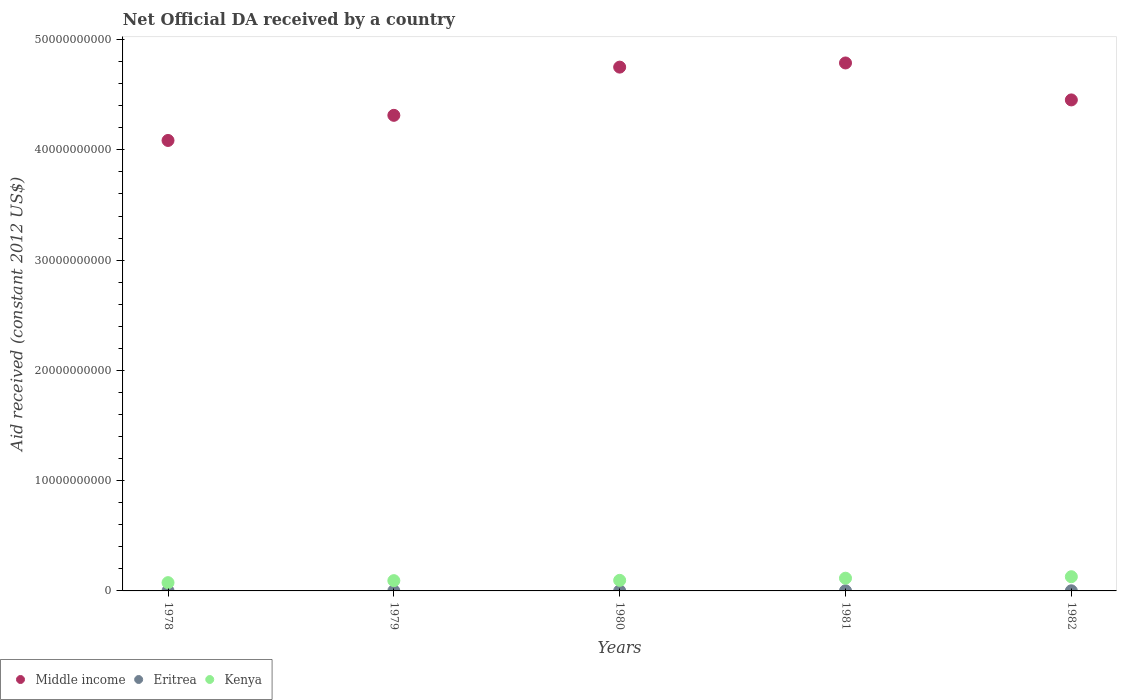What is the net official development assistance aid received in Kenya in 1978?
Your answer should be compact. 7.51e+08. Across all years, what is the maximum net official development assistance aid received in Eritrea?
Offer a very short reply. 1.46e+07. Across all years, what is the minimum net official development assistance aid received in Kenya?
Give a very brief answer. 7.51e+08. In which year was the net official development assistance aid received in Middle income maximum?
Offer a terse response. 1981. In which year was the net official development assistance aid received in Kenya minimum?
Provide a short and direct response. 1978. What is the total net official development assistance aid received in Eritrea in the graph?
Provide a succinct answer. 6.26e+07. What is the difference between the net official development assistance aid received in Eritrea in 1978 and that in 1980?
Your answer should be compact. 3.21e+06. What is the difference between the net official development assistance aid received in Middle income in 1979 and the net official development assistance aid received in Kenya in 1981?
Provide a short and direct response. 4.20e+1. What is the average net official development assistance aid received in Middle income per year?
Keep it short and to the point. 4.48e+1. In the year 1981, what is the difference between the net official development assistance aid received in Eritrea and net official development assistance aid received in Kenya?
Make the answer very short. -1.14e+09. In how many years, is the net official development assistance aid received in Middle income greater than 20000000000 US$?
Ensure brevity in your answer.  5. What is the ratio of the net official development assistance aid received in Eritrea in 1978 to that in 1980?
Offer a terse response. 1.28. Is the difference between the net official development assistance aid received in Eritrea in 1981 and 1982 greater than the difference between the net official development assistance aid received in Kenya in 1981 and 1982?
Your answer should be very brief. Yes. What is the difference between the highest and the second highest net official development assistance aid received in Middle income?
Ensure brevity in your answer.  3.77e+08. What is the difference between the highest and the lowest net official development assistance aid received in Kenya?
Ensure brevity in your answer.  5.38e+08. Is the sum of the net official development assistance aid received in Eritrea in 1979 and 1982 greater than the maximum net official development assistance aid received in Middle income across all years?
Ensure brevity in your answer.  No. Does the net official development assistance aid received in Eritrea monotonically increase over the years?
Offer a terse response. No. Is the net official development assistance aid received in Eritrea strictly greater than the net official development assistance aid received in Middle income over the years?
Make the answer very short. No. Does the graph contain any zero values?
Ensure brevity in your answer.  No. Where does the legend appear in the graph?
Ensure brevity in your answer.  Bottom left. How are the legend labels stacked?
Make the answer very short. Horizontal. What is the title of the graph?
Your answer should be compact. Net Official DA received by a country. Does "Faeroe Islands" appear as one of the legend labels in the graph?
Offer a very short reply. No. What is the label or title of the X-axis?
Keep it short and to the point. Years. What is the label or title of the Y-axis?
Your answer should be very brief. Aid received (constant 2012 US$). What is the Aid received (constant 2012 US$) of Middle income in 1978?
Give a very brief answer. 4.09e+1. What is the Aid received (constant 2012 US$) of Eritrea in 1978?
Ensure brevity in your answer.  1.46e+07. What is the Aid received (constant 2012 US$) of Kenya in 1978?
Make the answer very short. 7.51e+08. What is the Aid received (constant 2012 US$) in Middle income in 1979?
Keep it short and to the point. 4.31e+1. What is the Aid received (constant 2012 US$) of Eritrea in 1979?
Give a very brief answer. 1.10e+07. What is the Aid received (constant 2012 US$) in Kenya in 1979?
Keep it short and to the point. 9.32e+08. What is the Aid received (constant 2012 US$) in Middle income in 1980?
Your answer should be compact. 4.75e+1. What is the Aid received (constant 2012 US$) of Eritrea in 1980?
Ensure brevity in your answer.  1.14e+07. What is the Aid received (constant 2012 US$) in Kenya in 1980?
Your answer should be compact. 9.59e+08. What is the Aid received (constant 2012 US$) of Middle income in 1981?
Give a very brief answer. 4.79e+1. What is the Aid received (constant 2012 US$) in Eritrea in 1981?
Provide a succinct answer. 1.42e+07. What is the Aid received (constant 2012 US$) in Kenya in 1981?
Your answer should be compact. 1.15e+09. What is the Aid received (constant 2012 US$) in Middle income in 1982?
Your answer should be very brief. 4.45e+1. What is the Aid received (constant 2012 US$) in Eritrea in 1982?
Offer a very short reply. 1.15e+07. What is the Aid received (constant 2012 US$) in Kenya in 1982?
Your answer should be very brief. 1.29e+09. Across all years, what is the maximum Aid received (constant 2012 US$) of Middle income?
Make the answer very short. 4.79e+1. Across all years, what is the maximum Aid received (constant 2012 US$) in Eritrea?
Provide a succinct answer. 1.46e+07. Across all years, what is the maximum Aid received (constant 2012 US$) of Kenya?
Make the answer very short. 1.29e+09. Across all years, what is the minimum Aid received (constant 2012 US$) of Middle income?
Offer a very short reply. 4.09e+1. Across all years, what is the minimum Aid received (constant 2012 US$) of Eritrea?
Make the answer very short. 1.10e+07. Across all years, what is the minimum Aid received (constant 2012 US$) of Kenya?
Offer a terse response. 7.51e+08. What is the total Aid received (constant 2012 US$) in Middle income in the graph?
Your answer should be compact. 2.24e+11. What is the total Aid received (constant 2012 US$) in Eritrea in the graph?
Keep it short and to the point. 6.26e+07. What is the total Aid received (constant 2012 US$) in Kenya in the graph?
Provide a succinct answer. 5.08e+09. What is the difference between the Aid received (constant 2012 US$) in Middle income in 1978 and that in 1979?
Offer a very short reply. -2.28e+09. What is the difference between the Aid received (constant 2012 US$) in Eritrea in 1978 and that in 1979?
Give a very brief answer. 3.60e+06. What is the difference between the Aid received (constant 2012 US$) in Kenya in 1978 and that in 1979?
Your answer should be compact. -1.81e+08. What is the difference between the Aid received (constant 2012 US$) in Middle income in 1978 and that in 1980?
Offer a terse response. -6.65e+09. What is the difference between the Aid received (constant 2012 US$) in Eritrea in 1978 and that in 1980?
Your response must be concise. 3.21e+06. What is the difference between the Aid received (constant 2012 US$) in Kenya in 1978 and that in 1980?
Provide a succinct answer. -2.08e+08. What is the difference between the Aid received (constant 2012 US$) in Middle income in 1978 and that in 1981?
Offer a terse response. -7.03e+09. What is the difference between the Aid received (constant 2012 US$) of Eritrea in 1978 and that in 1981?
Your answer should be compact. 4.40e+05. What is the difference between the Aid received (constant 2012 US$) of Kenya in 1978 and that in 1981?
Give a very brief answer. -4.03e+08. What is the difference between the Aid received (constant 2012 US$) in Middle income in 1978 and that in 1982?
Give a very brief answer. -3.68e+09. What is the difference between the Aid received (constant 2012 US$) in Eritrea in 1978 and that in 1982?
Provide a short and direct response. 3.06e+06. What is the difference between the Aid received (constant 2012 US$) in Kenya in 1978 and that in 1982?
Make the answer very short. -5.38e+08. What is the difference between the Aid received (constant 2012 US$) of Middle income in 1979 and that in 1980?
Give a very brief answer. -4.37e+09. What is the difference between the Aid received (constant 2012 US$) of Eritrea in 1979 and that in 1980?
Offer a very short reply. -3.90e+05. What is the difference between the Aid received (constant 2012 US$) of Kenya in 1979 and that in 1980?
Offer a very short reply. -2.66e+07. What is the difference between the Aid received (constant 2012 US$) in Middle income in 1979 and that in 1981?
Offer a very short reply. -4.75e+09. What is the difference between the Aid received (constant 2012 US$) in Eritrea in 1979 and that in 1981?
Give a very brief answer. -3.16e+06. What is the difference between the Aid received (constant 2012 US$) in Kenya in 1979 and that in 1981?
Your answer should be very brief. -2.22e+08. What is the difference between the Aid received (constant 2012 US$) of Middle income in 1979 and that in 1982?
Offer a very short reply. -1.40e+09. What is the difference between the Aid received (constant 2012 US$) in Eritrea in 1979 and that in 1982?
Offer a terse response. -5.40e+05. What is the difference between the Aid received (constant 2012 US$) of Kenya in 1979 and that in 1982?
Ensure brevity in your answer.  -3.56e+08. What is the difference between the Aid received (constant 2012 US$) in Middle income in 1980 and that in 1981?
Ensure brevity in your answer.  -3.77e+08. What is the difference between the Aid received (constant 2012 US$) of Eritrea in 1980 and that in 1981?
Keep it short and to the point. -2.77e+06. What is the difference between the Aid received (constant 2012 US$) of Kenya in 1980 and that in 1981?
Offer a terse response. -1.95e+08. What is the difference between the Aid received (constant 2012 US$) of Middle income in 1980 and that in 1982?
Make the answer very short. 2.97e+09. What is the difference between the Aid received (constant 2012 US$) of Kenya in 1980 and that in 1982?
Keep it short and to the point. -3.30e+08. What is the difference between the Aid received (constant 2012 US$) in Middle income in 1981 and that in 1982?
Ensure brevity in your answer.  3.35e+09. What is the difference between the Aid received (constant 2012 US$) in Eritrea in 1981 and that in 1982?
Provide a succinct answer. 2.62e+06. What is the difference between the Aid received (constant 2012 US$) in Kenya in 1981 and that in 1982?
Ensure brevity in your answer.  -1.35e+08. What is the difference between the Aid received (constant 2012 US$) of Middle income in 1978 and the Aid received (constant 2012 US$) of Eritrea in 1979?
Keep it short and to the point. 4.08e+1. What is the difference between the Aid received (constant 2012 US$) in Middle income in 1978 and the Aid received (constant 2012 US$) in Kenya in 1979?
Offer a very short reply. 3.99e+1. What is the difference between the Aid received (constant 2012 US$) in Eritrea in 1978 and the Aid received (constant 2012 US$) in Kenya in 1979?
Make the answer very short. -9.18e+08. What is the difference between the Aid received (constant 2012 US$) of Middle income in 1978 and the Aid received (constant 2012 US$) of Eritrea in 1980?
Provide a succinct answer. 4.08e+1. What is the difference between the Aid received (constant 2012 US$) of Middle income in 1978 and the Aid received (constant 2012 US$) of Kenya in 1980?
Your answer should be very brief. 3.99e+1. What is the difference between the Aid received (constant 2012 US$) of Eritrea in 1978 and the Aid received (constant 2012 US$) of Kenya in 1980?
Give a very brief answer. -9.44e+08. What is the difference between the Aid received (constant 2012 US$) of Middle income in 1978 and the Aid received (constant 2012 US$) of Eritrea in 1981?
Offer a very short reply. 4.08e+1. What is the difference between the Aid received (constant 2012 US$) of Middle income in 1978 and the Aid received (constant 2012 US$) of Kenya in 1981?
Give a very brief answer. 3.97e+1. What is the difference between the Aid received (constant 2012 US$) in Eritrea in 1978 and the Aid received (constant 2012 US$) in Kenya in 1981?
Give a very brief answer. -1.14e+09. What is the difference between the Aid received (constant 2012 US$) in Middle income in 1978 and the Aid received (constant 2012 US$) in Eritrea in 1982?
Give a very brief answer. 4.08e+1. What is the difference between the Aid received (constant 2012 US$) in Middle income in 1978 and the Aid received (constant 2012 US$) in Kenya in 1982?
Your answer should be very brief. 3.96e+1. What is the difference between the Aid received (constant 2012 US$) of Eritrea in 1978 and the Aid received (constant 2012 US$) of Kenya in 1982?
Keep it short and to the point. -1.27e+09. What is the difference between the Aid received (constant 2012 US$) in Middle income in 1979 and the Aid received (constant 2012 US$) in Eritrea in 1980?
Provide a short and direct response. 4.31e+1. What is the difference between the Aid received (constant 2012 US$) of Middle income in 1979 and the Aid received (constant 2012 US$) of Kenya in 1980?
Give a very brief answer. 4.22e+1. What is the difference between the Aid received (constant 2012 US$) of Eritrea in 1979 and the Aid received (constant 2012 US$) of Kenya in 1980?
Your response must be concise. -9.48e+08. What is the difference between the Aid received (constant 2012 US$) in Middle income in 1979 and the Aid received (constant 2012 US$) in Eritrea in 1981?
Your answer should be very brief. 4.31e+1. What is the difference between the Aid received (constant 2012 US$) of Middle income in 1979 and the Aid received (constant 2012 US$) of Kenya in 1981?
Offer a very short reply. 4.20e+1. What is the difference between the Aid received (constant 2012 US$) in Eritrea in 1979 and the Aid received (constant 2012 US$) in Kenya in 1981?
Give a very brief answer. -1.14e+09. What is the difference between the Aid received (constant 2012 US$) of Middle income in 1979 and the Aid received (constant 2012 US$) of Eritrea in 1982?
Offer a terse response. 4.31e+1. What is the difference between the Aid received (constant 2012 US$) in Middle income in 1979 and the Aid received (constant 2012 US$) in Kenya in 1982?
Offer a terse response. 4.18e+1. What is the difference between the Aid received (constant 2012 US$) of Eritrea in 1979 and the Aid received (constant 2012 US$) of Kenya in 1982?
Give a very brief answer. -1.28e+09. What is the difference between the Aid received (constant 2012 US$) in Middle income in 1980 and the Aid received (constant 2012 US$) in Eritrea in 1981?
Keep it short and to the point. 4.75e+1. What is the difference between the Aid received (constant 2012 US$) in Middle income in 1980 and the Aid received (constant 2012 US$) in Kenya in 1981?
Your response must be concise. 4.64e+1. What is the difference between the Aid received (constant 2012 US$) in Eritrea in 1980 and the Aid received (constant 2012 US$) in Kenya in 1981?
Provide a short and direct response. -1.14e+09. What is the difference between the Aid received (constant 2012 US$) in Middle income in 1980 and the Aid received (constant 2012 US$) in Eritrea in 1982?
Ensure brevity in your answer.  4.75e+1. What is the difference between the Aid received (constant 2012 US$) in Middle income in 1980 and the Aid received (constant 2012 US$) in Kenya in 1982?
Provide a short and direct response. 4.62e+1. What is the difference between the Aid received (constant 2012 US$) of Eritrea in 1980 and the Aid received (constant 2012 US$) of Kenya in 1982?
Offer a terse response. -1.28e+09. What is the difference between the Aid received (constant 2012 US$) of Middle income in 1981 and the Aid received (constant 2012 US$) of Eritrea in 1982?
Offer a terse response. 4.79e+1. What is the difference between the Aid received (constant 2012 US$) of Middle income in 1981 and the Aid received (constant 2012 US$) of Kenya in 1982?
Give a very brief answer. 4.66e+1. What is the difference between the Aid received (constant 2012 US$) of Eritrea in 1981 and the Aid received (constant 2012 US$) of Kenya in 1982?
Keep it short and to the point. -1.27e+09. What is the average Aid received (constant 2012 US$) in Middle income per year?
Provide a succinct answer. 4.48e+1. What is the average Aid received (constant 2012 US$) of Eritrea per year?
Your answer should be compact. 1.25e+07. What is the average Aid received (constant 2012 US$) of Kenya per year?
Your answer should be very brief. 1.02e+09. In the year 1978, what is the difference between the Aid received (constant 2012 US$) of Middle income and Aid received (constant 2012 US$) of Eritrea?
Give a very brief answer. 4.08e+1. In the year 1978, what is the difference between the Aid received (constant 2012 US$) of Middle income and Aid received (constant 2012 US$) of Kenya?
Ensure brevity in your answer.  4.01e+1. In the year 1978, what is the difference between the Aid received (constant 2012 US$) in Eritrea and Aid received (constant 2012 US$) in Kenya?
Offer a terse response. -7.36e+08. In the year 1979, what is the difference between the Aid received (constant 2012 US$) of Middle income and Aid received (constant 2012 US$) of Eritrea?
Offer a terse response. 4.31e+1. In the year 1979, what is the difference between the Aid received (constant 2012 US$) in Middle income and Aid received (constant 2012 US$) in Kenya?
Make the answer very short. 4.22e+1. In the year 1979, what is the difference between the Aid received (constant 2012 US$) of Eritrea and Aid received (constant 2012 US$) of Kenya?
Offer a terse response. -9.21e+08. In the year 1980, what is the difference between the Aid received (constant 2012 US$) of Middle income and Aid received (constant 2012 US$) of Eritrea?
Your answer should be compact. 4.75e+1. In the year 1980, what is the difference between the Aid received (constant 2012 US$) of Middle income and Aid received (constant 2012 US$) of Kenya?
Provide a short and direct response. 4.65e+1. In the year 1980, what is the difference between the Aid received (constant 2012 US$) in Eritrea and Aid received (constant 2012 US$) in Kenya?
Offer a very short reply. -9.47e+08. In the year 1981, what is the difference between the Aid received (constant 2012 US$) in Middle income and Aid received (constant 2012 US$) in Eritrea?
Offer a very short reply. 4.79e+1. In the year 1981, what is the difference between the Aid received (constant 2012 US$) of Middle income and Aid received (constant 2012 US$) of Kenya?
Give a very brief answer. 4.67e+1. In the year 1981, what is the difference between the Aid received (constant 2012 US$) of Eritrea and Aid received (constant 2012 US$) of Kenya?
Provide a short and direct response. -1.14e+09. In the year 1982, what is the difference between the Aid received (constant 2012 US$) in Middle income and Aid received (constant 2012 US$) in Eritrea?
Give a very brief answer. 4.45e+1. In the year 1982, what is the difference between the Aid received (constant 2012 US$) of Middle income and Aid received (constant 2012 US$) of Kenya?
Your answer should be very brief. 4.32e+1. In the year 1982, what is the difference between the Aid received (constant 2012 US$) of Eritrea and Aid received (constant 2012 US$) of Kenya?
Keep it short and to the point. -1.28e+09. What is the ratio of the Aid received (constant 2012 US$) in Middle income in 1978 to that in 1979?
Offer a terse response. 0.95. What is the ratio of the Aid received (constant 2012 US$) of Eritrea in 1978 to that in 1979?
Make the answer very short. 1.33. What is the ratio of the Aid received (constant 2012 US$) of Kenya in 1978 to that in 1979?
Give a very brief answer. 0.81. What is the ratio of the Aid received (constant 2012 US$) in Middle income in 1978 to that in 1980?
Your response must be concise. 0.86. What is the ratio of the Aid received (constant 2012 US$) in Eritrea in 1978 to that in 1980?
Make the answer very short. 1.28. What is the ratio of the Aid received (constant 2012 US$) in Kenya in 1978 to that in 1980?
Offer a very short reply. 0.78. What is the ratio of the Aid received (constant 2012 US$) of Middle income in 1978 to that in 1981?
Offer a terse response. 0.85. What is the ratio of the Aid received (constant 2012 US$) in Eritrea in 1978 to that in 1981?
Provide a succinct answer. 1.03. What is the ratio of the Aid received (constant 2012 US$) in Kenya in 1978 to that in 1981?
Provide a short and direct response. 0.65. What is the ratio of the Aid received (constant 2012 US$) of Middle income in 1978 to that in 1982?
Offer a terse response. 0.92. What is the ratio of the Aid received (constant 2012 US$) of Eritrea in 1978 to that in 1982?
Offer a terse response. 1.27. What is the ratio of the Aid received (constant 2012 US$) of Kenya in 1978 to that in 1982?
Provide a succinct answer. 0.58. What is the ratio of the Aid received (constant 2012 US$) of Middle income in 1979 to that in 1980?
Provide a short and direct response. 0.91. What is the ratio of the Aid received (constant 2012 US$) of Eritrea in 1979 to that in 1980?
Provide a short and direct response. 0.97. What is the ratio of the Aid received (constant 2012 US$) in Kenya in 1979 to that in 1980?
Offer a very short reply. 0.97. What is the ratio of the Aid received (constant 2012 US$) of Middle income in 1979 to that in 1981?
Give a very brief answer. 0.9. What is the ratio of the Aid received (constant 2012 US$) in Eritrea in 1979 to that in 1981?
Keep it short and to the point. 0.78. What is the ratio of the Aid received (constant 2012 US$) of Kenya in 1979 to that in 1981?
Provide a short and direct response. 0.81. What is the ratio of the Aid received (constant 2012 US$) of Middle income in 1979 to that in 1982?
Your answer should be very brief. 0.97. What is the ratio of the Aid received (constant 2012 US$) of Eritrea in 1979 to that in 1982?
Ensure brevity in your answer.  0.95. What is the ratio of the Aid received (constant 2012 US$) of Kenya in 1979 to that in 1982?
Give a very brief answer. 0.72. What is the ratio of the Aid received (constant 2012 US$) of Eritrea in 1980 to that in 1981?
Your answer should be compact. 0.8. What is the ratio of the Aid received (constant 2012 US$) in Kenya in 1980 to that in 1981?
Offer a terse response. 0.83. What is the ratio of the Aid received (constant 2012 US$) of Middle income in 1980 to that in 1982?
Ensure brevity in your answer.  1.07. What is the ratio of the Aid received (constant 2012 US$) of Kenya in 1980 to that in 1982?
Keep it short and to the point. 0.74. What is the ratio of the Aid received (constant 2012 US$) of Middle income in 1981 to that in 1982?
Make the answer very short. 1.08. What is the ratio of the Aid received (constant 2012 US$) of Eritrea in 1981 to that in 1982?
Provide a short and direct response. 1.23. What is the ratio of the Aid received (constant 2012 US$) in Kenya in 1981 to that in 1982?
Your answer should be very brief. 0.9. What is the difference between the highest and the second highest Aid received (constant 2012 US$) in Middle income?
Make the answer very short. 3.77e+08. What is the difference between the highest and the second highest Aid received (constant 2012 US$) in Eritrea?
Your response must be concise. 4.40e+05. What is the difference between the highest and the second highest Aid received (constant 2012 US$) in Kenya?
Provide a short and direct response. 1.35e+08. What is the difference between the highest and the lowest Aid received (constant 2012 US$) in Middle income?
Give a very brief answer. 7.03e+09. What is the difference between the highest and the lowest Aid received (constant 2012 US$) in Eritrea?
Give a very brief answer. 3.60e+06. What is the difference between the highest and the lowest Aid received (constant 2012 US$) in Kenya?
Your response must be concise. 5.38e+08. 